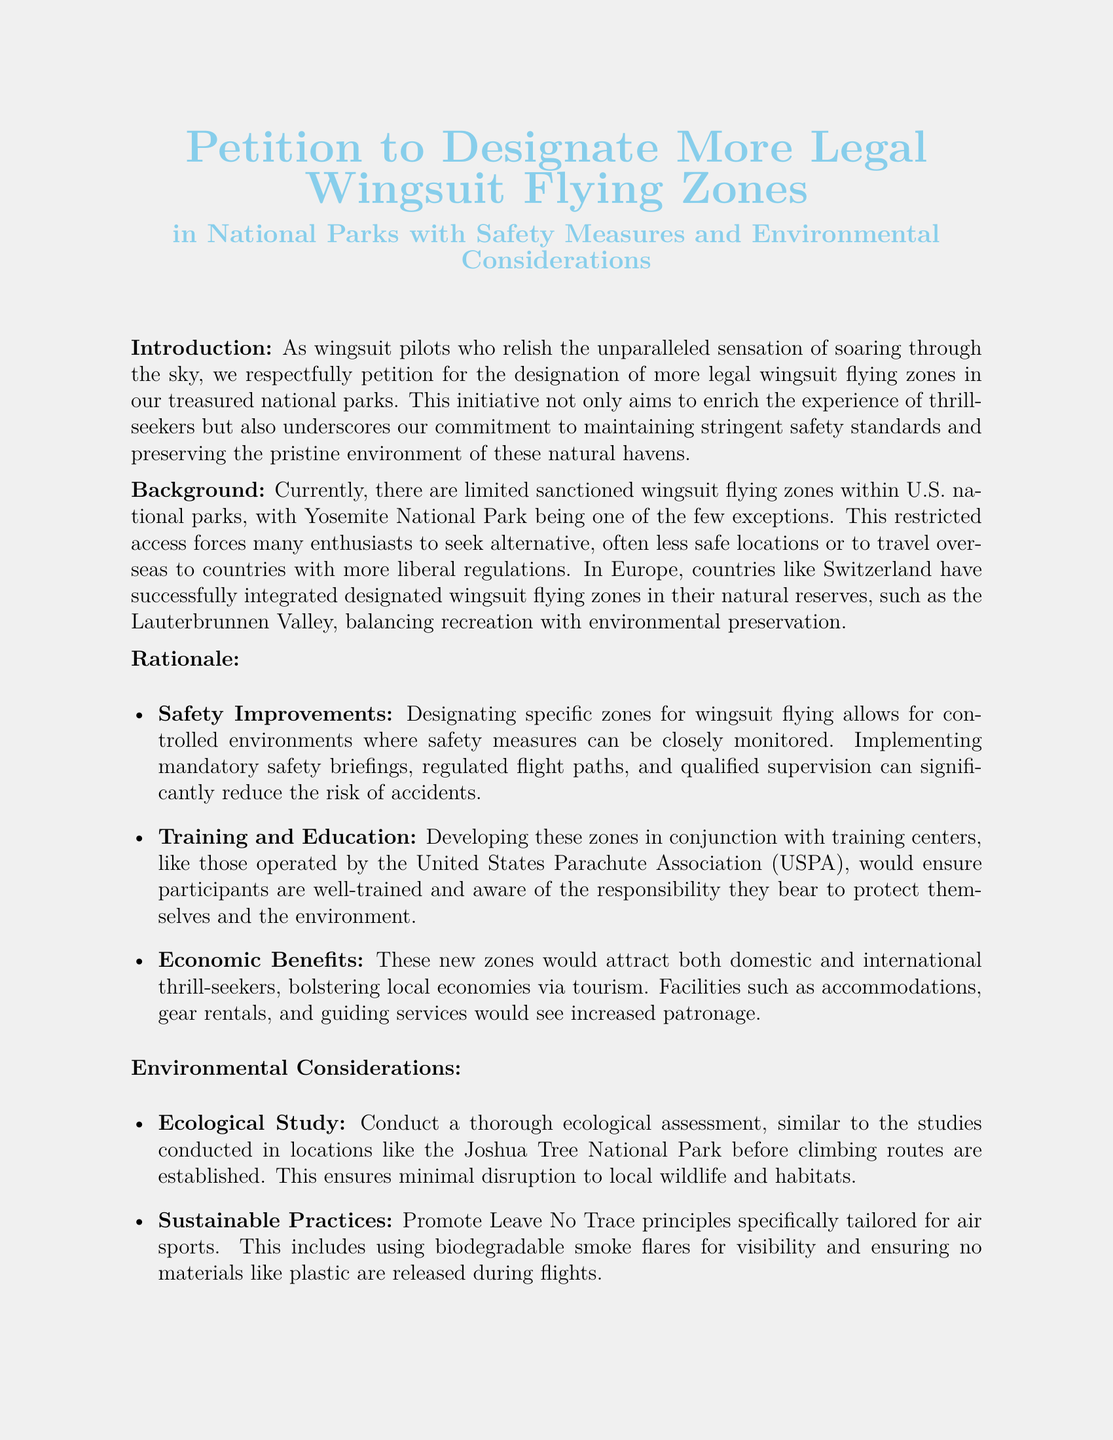What is the document's title? The title of the document is prominently displayed at the beginning and reads "Petition to Designate More Legal Wingsuit Flying Zones."
Answer: Petition to Designate More Legal Wingsuit Flying Zones What is the main purpose of the petition? The introduction explains that the purpose of the petition is to designate more legal wingsuit flying zones in national parks.
Answer: To designate more legal wingsuit flying zones Which national park is mentioned as having a sanctioned wingsuit zone? The background section specifies that Yosemite National Park is one of the few parks with a sanctioned wingsuit flying zone.
Answer: Yosemite National Park What are the proposed safety measures in the petition? The rationale section mentions several safety measures, including mandatory safety briefings and regulated flight paths.
Answer: Mandatory safety briefings, regulated flight paths Which organization is suggested to operate training centers? The rationale mentions that training centers could be developed in conjunction with the United States Parachute Association (USPA).
Answer: United States Parachute Association (USPA) What environmental principle is emphasized in the petition? The environmental considerations section promotes Leave No Trace principles as essential for air sports.
Answer: Leave No Trace principles What economic benefit is mentioned regarding the new zones? The rationale states that the new wingsuit flying zones would attract tourists and bolster local economies.
Answer: Attract tourists, bolster local economies What type of assessment is recommended before establishing flying zones? The document suggests conducting a thorough ecological assessment similar to those conducted in national parks before establishing climbing routes.
Answer: Thorough ecological assessment What feeling do wingsuit pilots experience while flying? The introduction describes wingsuit pilots as relishing the unparalleled sensation of soaring through the sky.
Answer: Unparalleled sensation of soaring through the sky 